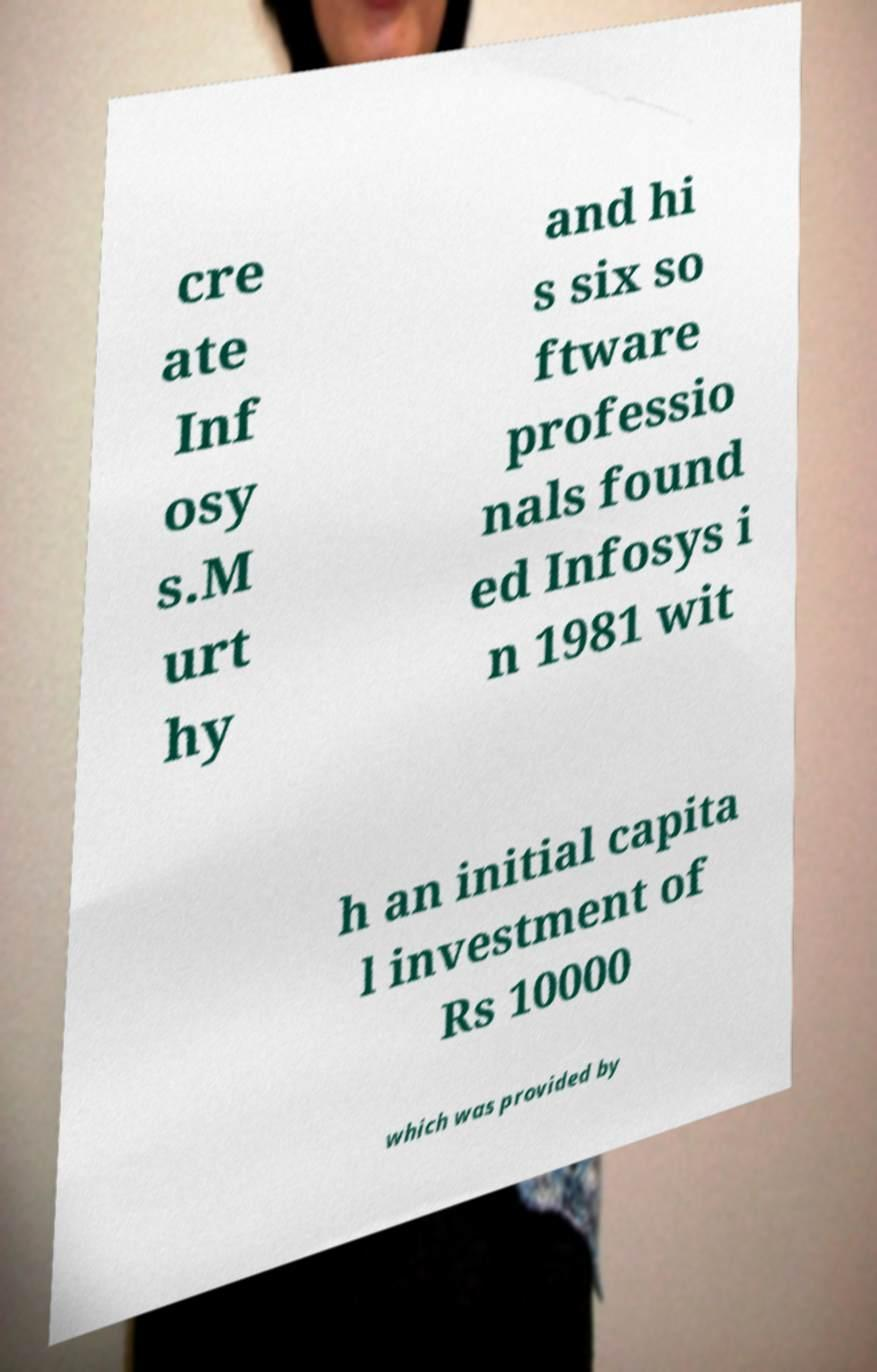There's text embedded in this image that I need extracted. Can you transcribe it verbatim? cre ate Inf osy s.M urt hy and hi s six so ftware professio nals found ed Infosys i n 1981 wit h an initial capita l investment of Rs 10000 which was provided by 